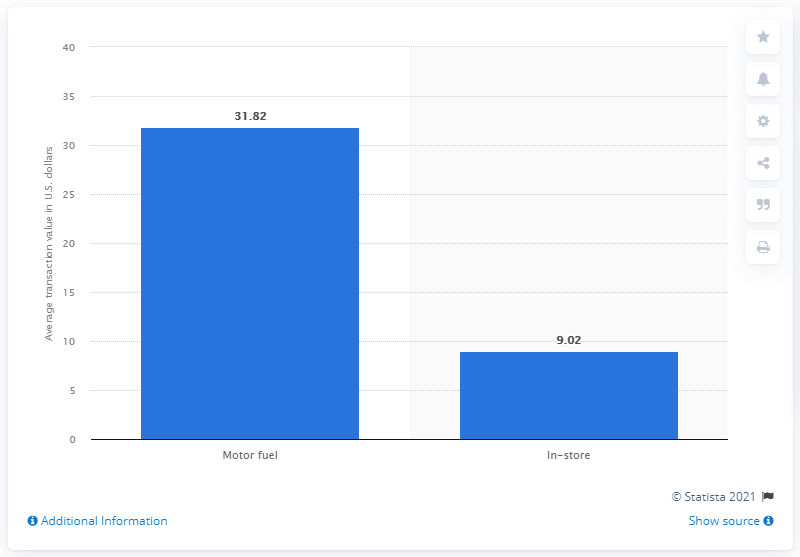Point out several critical features in this image. In 2019, the average value of in-store convenience store transactions was 9.02 dollars. The average value of motor fuel convenience stores in dollars per transaction in 2019 was 31.82. 